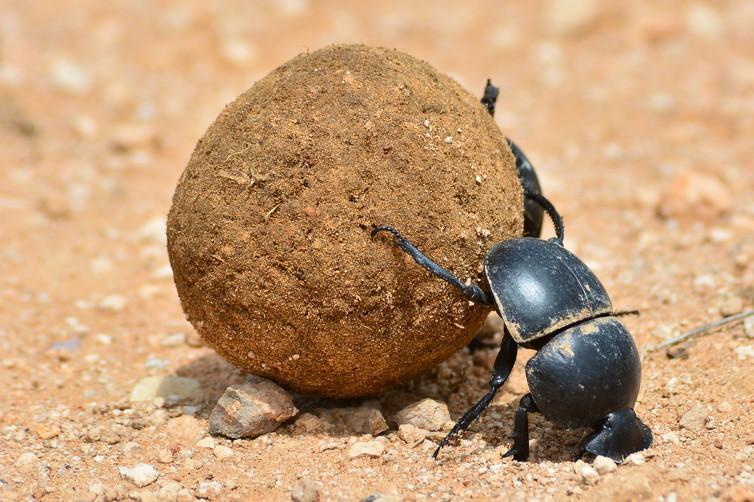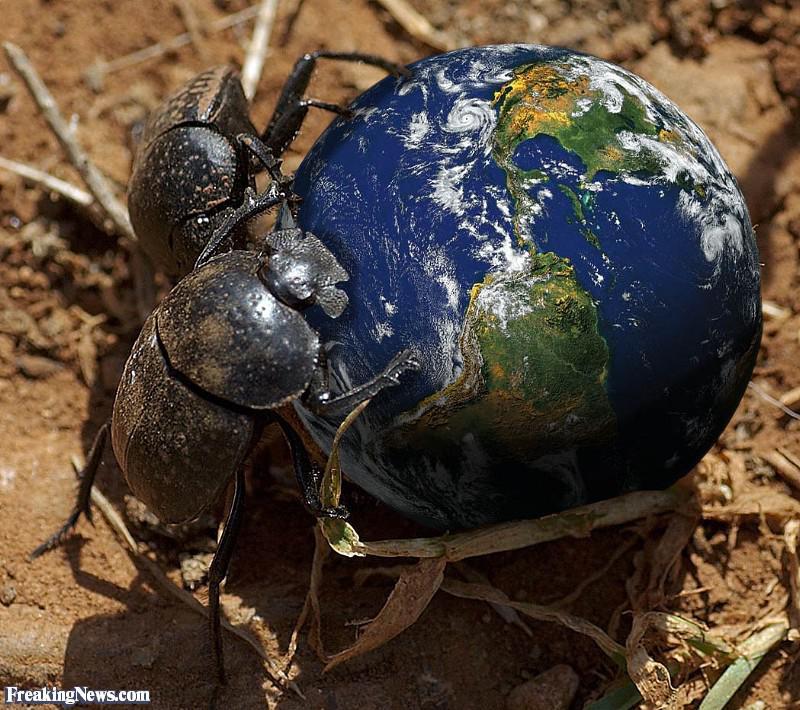The first image is the image on the left, the second image is the image on the right. Assess this claim about the two images: "The ball in one of the images is not brown.". Correct or not? Answer yes or no. Yes. The first image is the image on the left, the second image is the image on the right. Considering the images on both sides, is "An image shows two beetles in proximity to a blue ball." valid? Answer yes or no. Yes. 